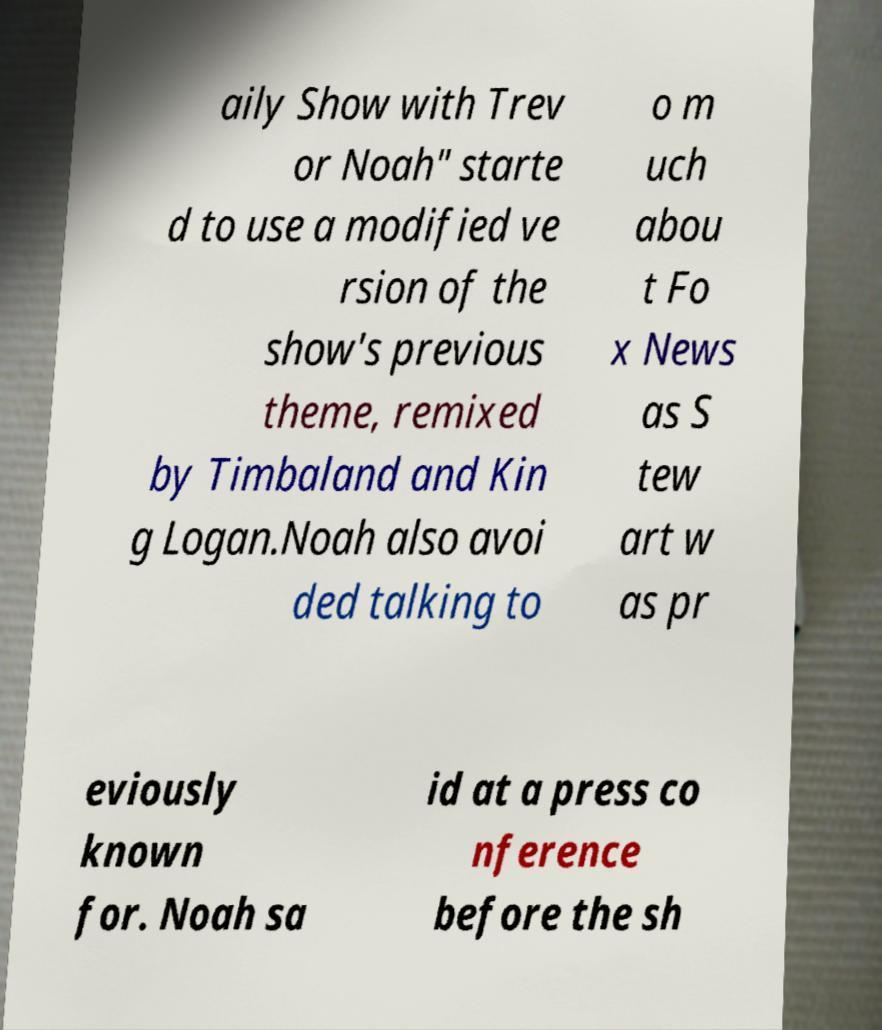Please identify and transcribe the text found in this image. aily Show with Trev or Noah" starte d to use a modified ve rsion of the show's previous theme, remixed by Timbaland and Kin g Logan.Noah also avoi ded talking to o m uch abou t Fo x News as S tew art w as pr eviously known for. Noah sa id at a press co nference before the sh 